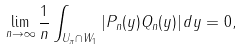Convert formula to latex. <formula><loc_0><loc_0><loc_500><loc_500>\lim _ { n \to \infty } \frac { 1 } { n } \int _ { U _ { \pi } \cap W _ { 1 } } | P _ { n } ( y ) Q _ { n } ( y ) | \, d y = 0 ,</formula> 